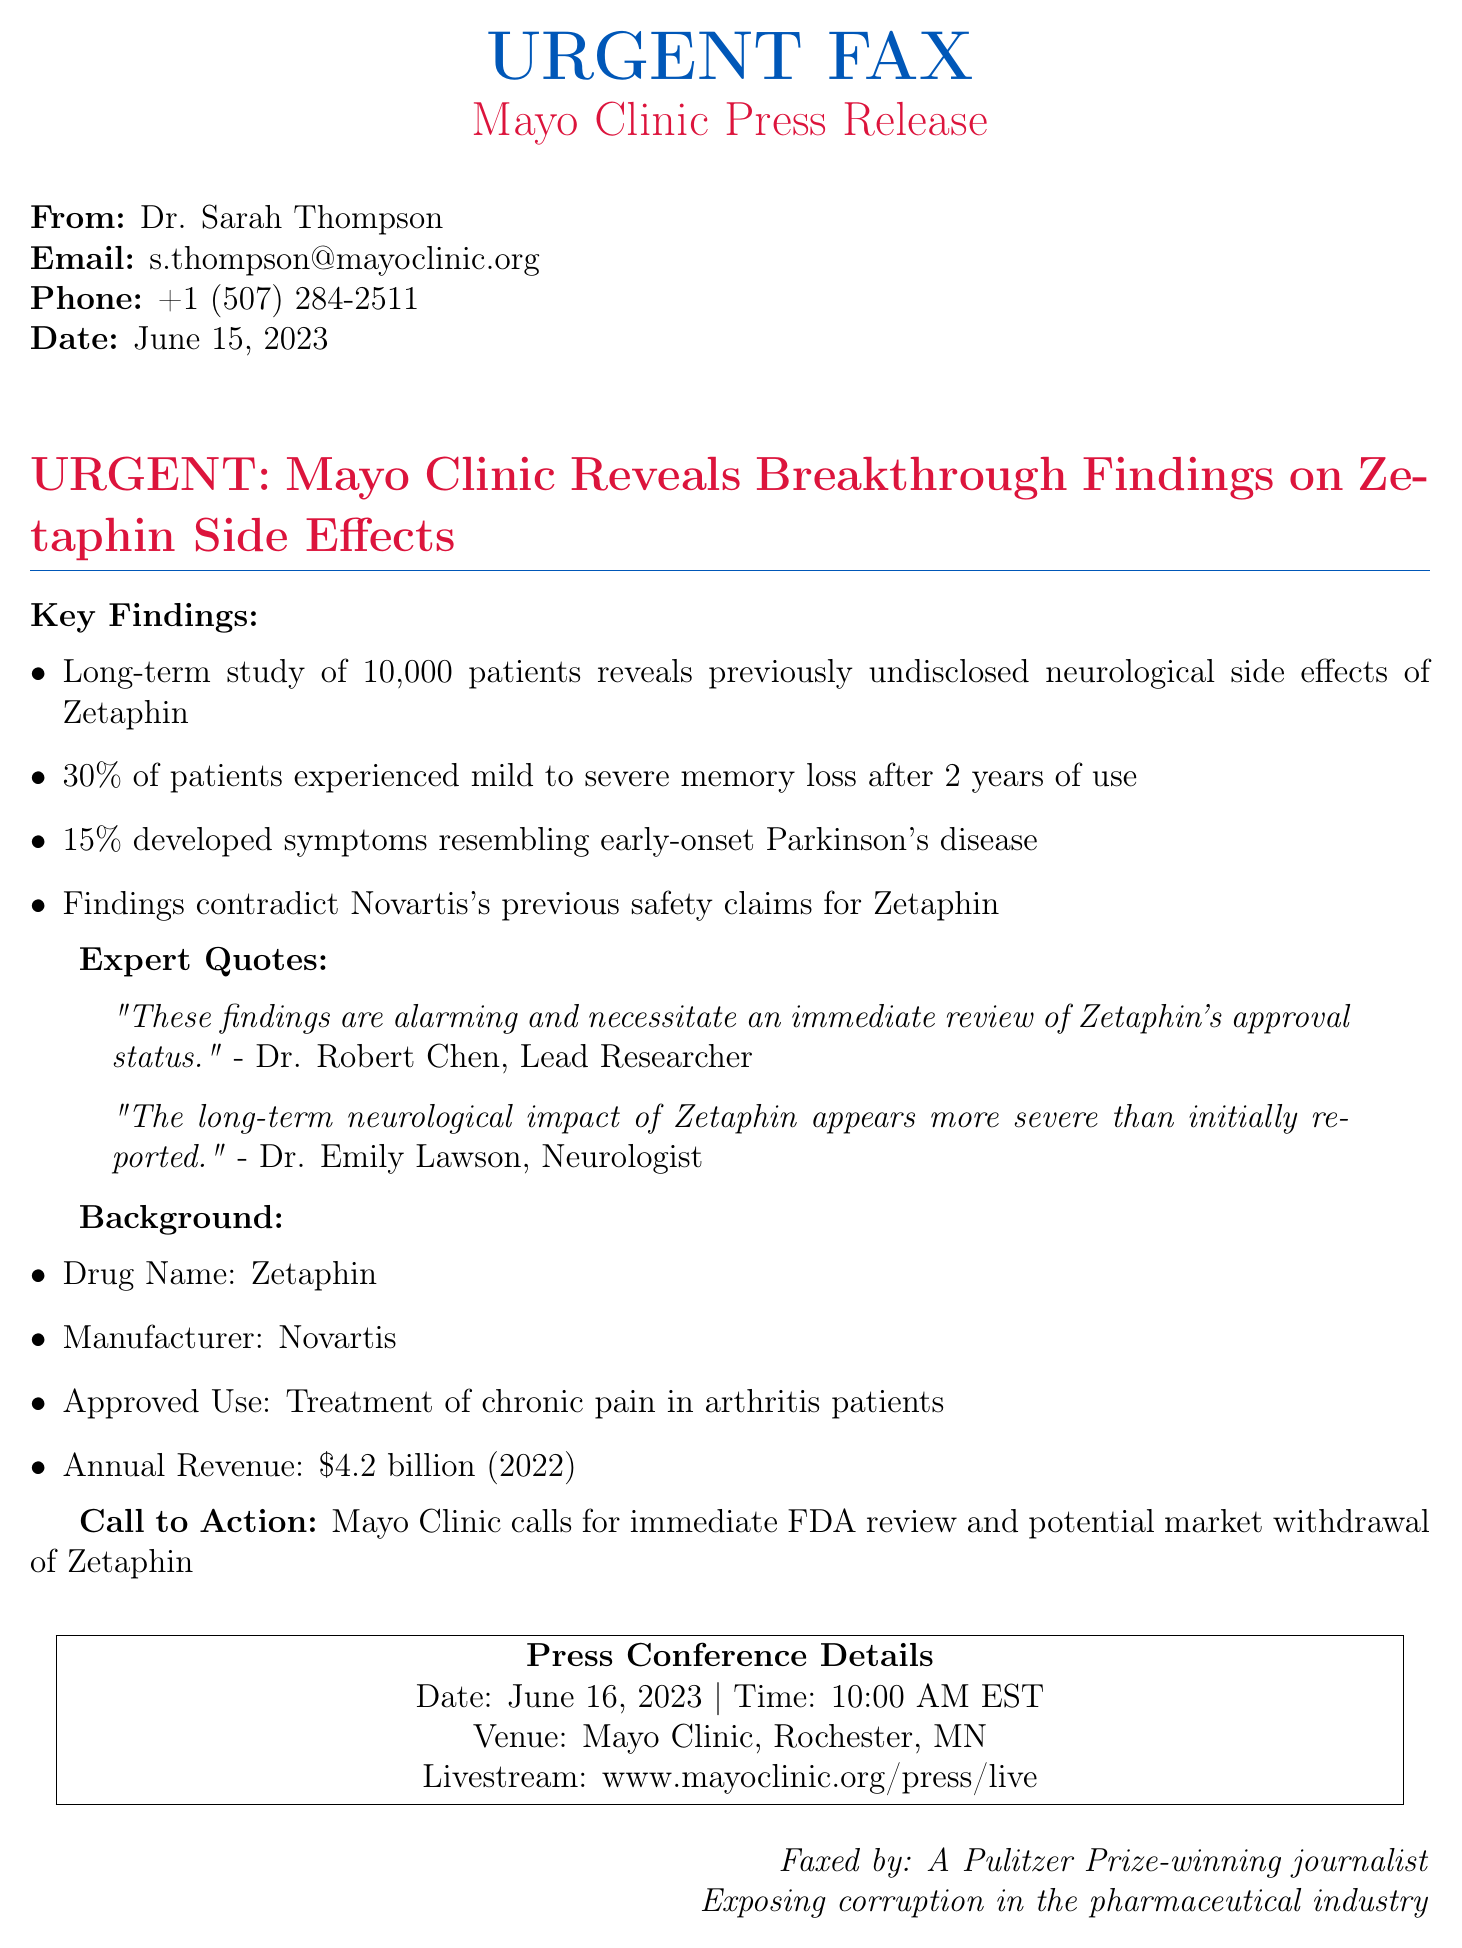What date was the press release issued? The date of the press release is specified at the top of the document.
Answer: June 15, 2023 What percentage of patients experienced memory loss? The document lists statistics regarding patient experiences related to Zetaphin, specifically mentioning memory loss.
Answer: 30% Who is the lead researcher mentioned in the document? The document attributes a quote to the lead researcher regarding the findings.
Answer: Dr. Robert Chen What is the approved use for Zetaphin? The document includes a line detailing what Zetaphin is approved for, specifically regarding its application.
Answer: Treatment of chronic pain in arthritis patients What is the annual revenue for Zetaphin's manufacturer in 2022? The annual revenue is explicitly mentioned in a bullet point in the document.
Answer: $4.2 billion What does the Mayo Clinic call for regarding Zetaphin? The document outlines a clear call to action from the Mayo Clinic concerning the drug's status.
Answer: Immediate FDA review and potential market withdrawal What time is the press conference scheduled for? The press conference details provide specific information on the timing of the event.
Answer: 10:00 AM EST What neurological symptom did 15% of patients develop? The document states a specific neurological symptom experienced by this percentage of patients.
Answer: Symptoms resembling early-onset Parkinson's disease What is the faxed note at the bottom attributed to? The footer of the document states the identity of the person faxing this information along with their professional achievement.
Answer: A Pulitzer Prize-winning journalist 